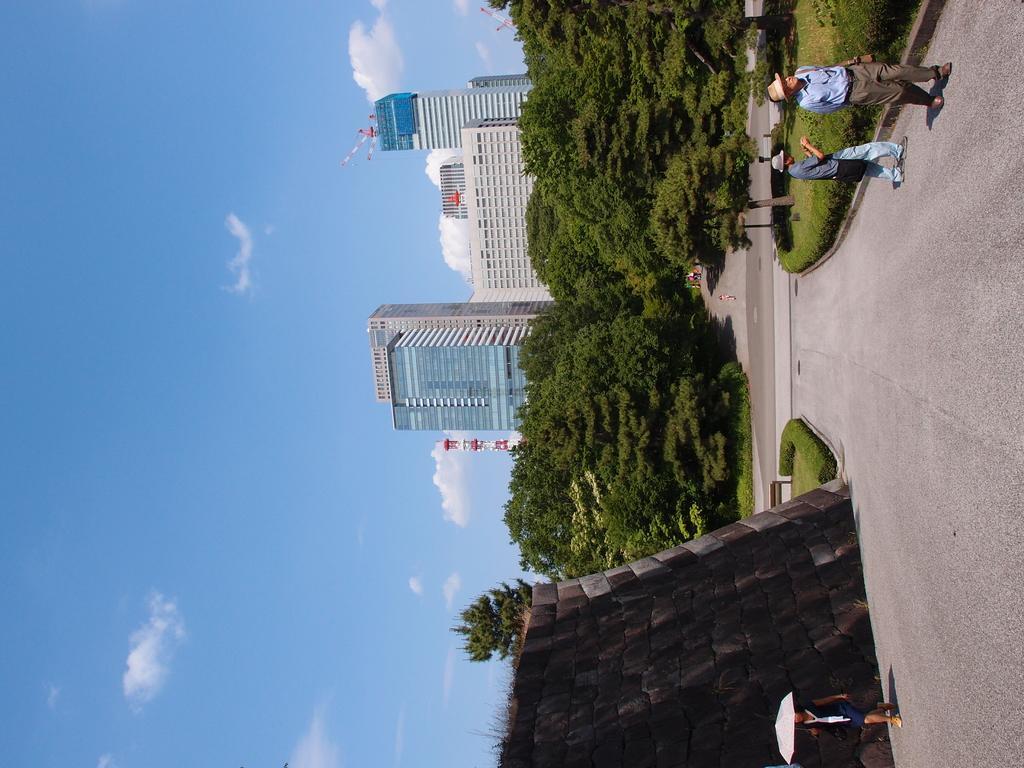In one or two sentences, can you explain what this image depicts? In this image we can see a road on the right side. Also there are two persons wearing cap. Also there is another person holding umbrella. There is a wall. And there are trees and buildings. Also there is sky with clouds. 